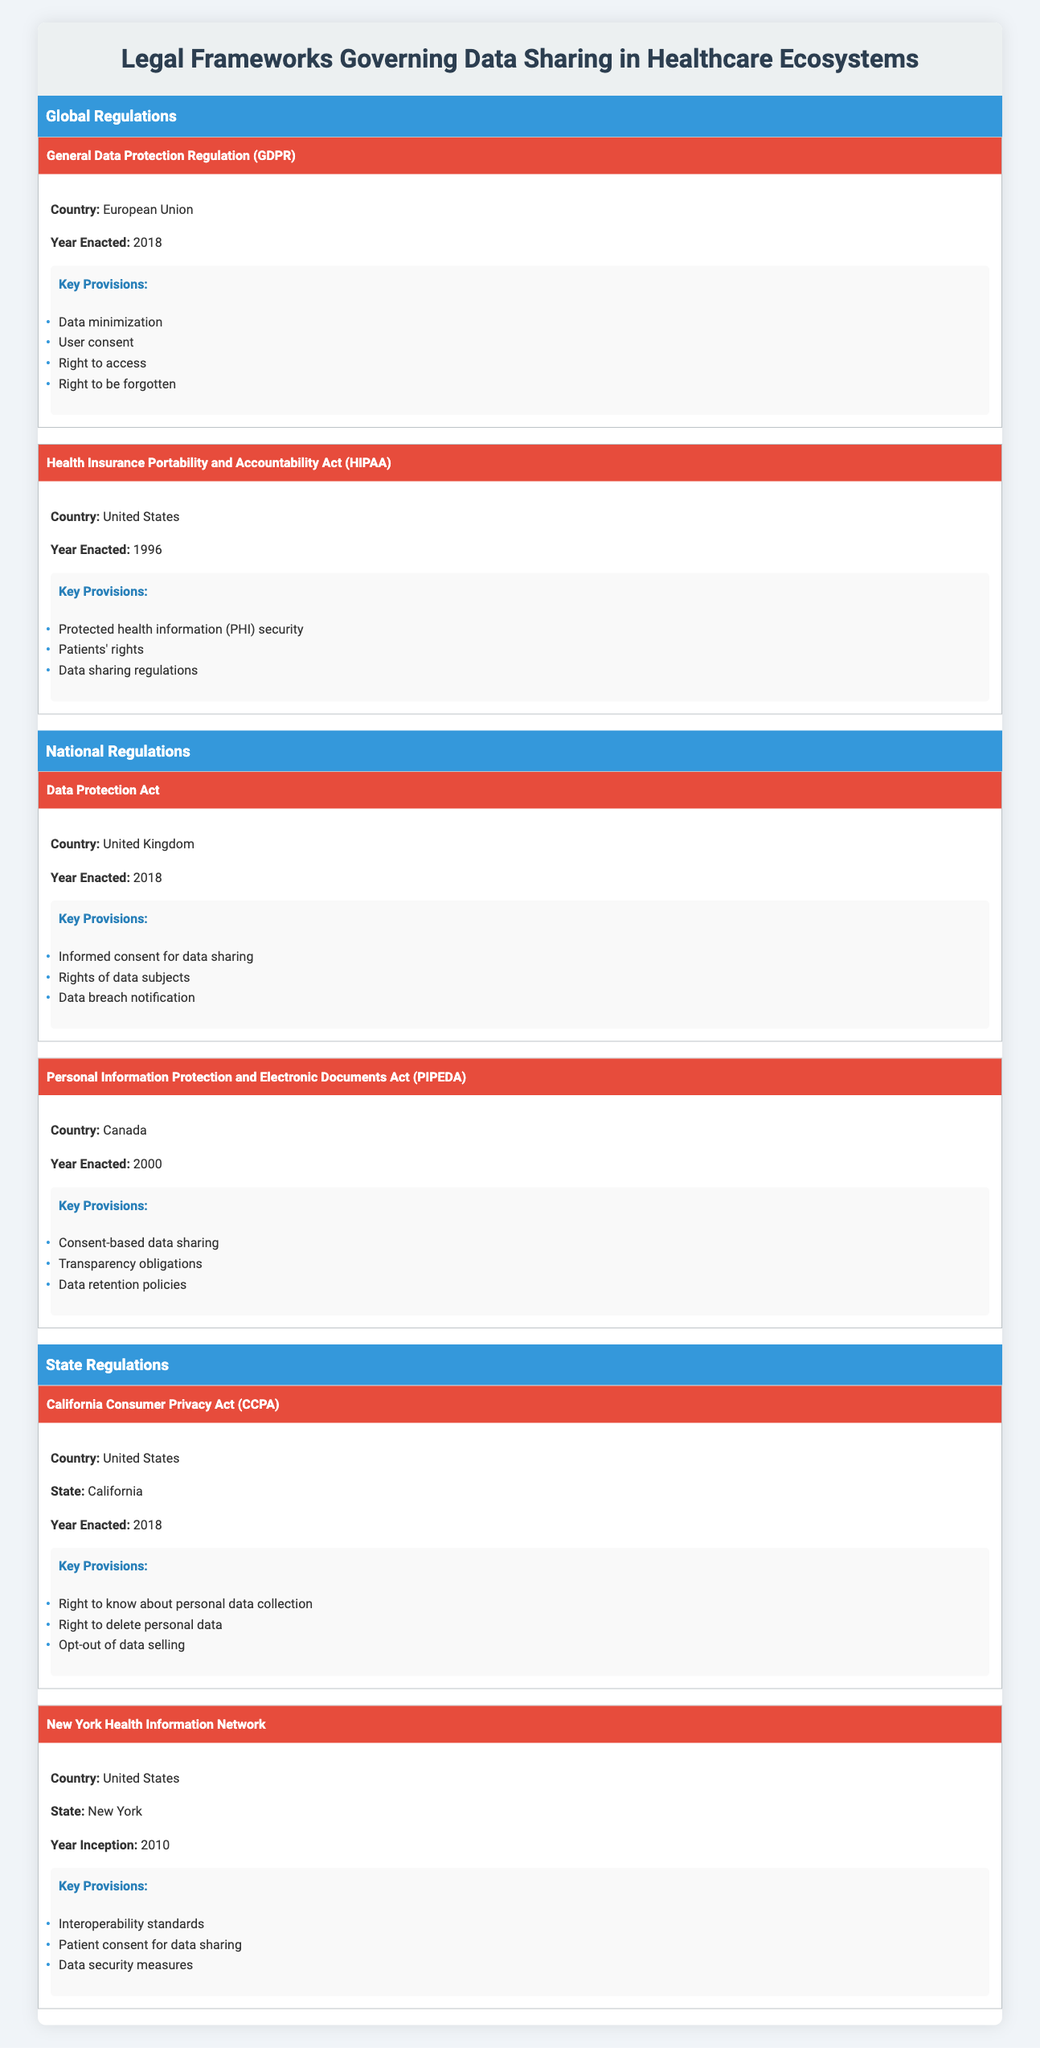What year was the General Data Protection Regulation enacted? The table indicates that the General Data Protection Regulation was enacted in the year 2018.
Answer: 2018 Which country implemented the Health Insurance Portability and Accountability Act? The table specifies that the Health Insurance Portability and Accountability Act was implemented in the United States.
Answer: United States Does the California Consumer Privacy Act allow individuals to opt-out of data selling? According to the table, one of the key provisions of the California Consumer Privacy Act is the right to opt-out of data selling, which confirms that individuals can do so.
Answer: Yes How many key provisions are outlined for the Data Protection Act? The Data Protection Act has three key provisions listed in the table: informed consent for data sharing, rights of data subjects, and data breach notification.
Answer: 3 Which act has a provision for the right to be forgotten? The table indicates that the General Data Protection Regulation includes the right to be forgotten as one of its key provisions.
Answer: General Data Protection Regulation What is the earliest year of enactment among the listed legal frameworks? The Health Insurance Portability and Accountability Act is the earliest as it was enacted in 1996, which is the lowest year listed in the table when compared to others.
Answer: 1996 In how many countries were the listed regulations enacted? The table shows that the regulations were enacted in four different countries: European Union, United States, United Kingdom, and Canada—totaling four countries.
Answer: 4 Are patients' rights mentioned as a key provision of the Health Insurance Portability and Accountability Act? The table confirms that patients' rights are listed as one of the key provisions of the Health Insurance Portability and Accountability Act, indicating that it is indeed mentioned.
Answer: Yes Which regulation is specific to New York and what year did it start? The New York Health Information Network is specific to New York, and the table states that it started in 2010.
Answer: New York Health Information Network, 2010 